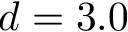Convert formula to latex. <formula><loc_0><loc_0><loc_500><loc_500>d = 3 . 0</formula> 